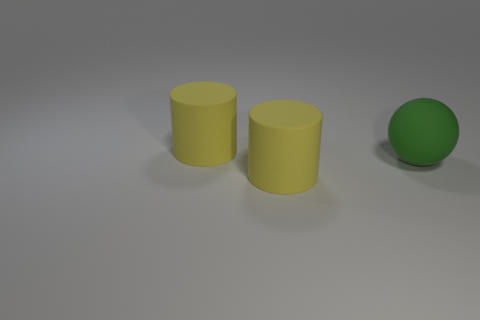What is the shape of the large green thing that is right of the yellow cylinder behind the large yellow object in front of the sphere?
Your answer should be very brief. Sphere. How many things are either big yellow rubber cylinders that are behind the green matte sphere or yellow rubber cylinders behind the big green ball?
Offer a terse response. 1. What size is the yellow rubber thing to the right of the large matte cylinder behind the big green thing?
Make the answer very short. Large. How big is the matte cylinder that is behind the green object?
Keep it short and to the point. Large. There is a big yellow cylinder behind the large ball; are there any big yellow cylinders that are in front of it?
Offer a terse response. Yes. How many rubber cylinders are both behind the matte ball and in front of the sphere?
Offer a terse response. 0. How many cylinders have the same material as the sphere?
Offer a very short reply. 2. Are there fewer balls than tiny gray objects?
Offer a very short reply. No. Is the color of the big matte cylinder that is behind the sphere the same as the rubber thing in front of the matte sphere?
Offer a terse response. Yes. Is the number of gray rubber blocks greater than the number of large green matte things?
Offer a very short reply. No. 